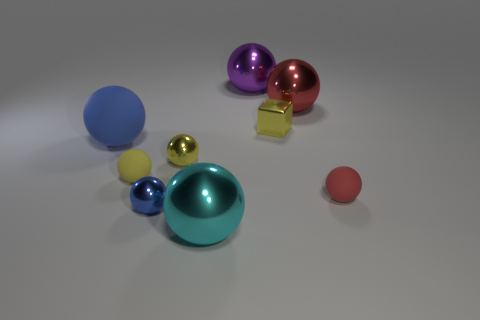Subtract all purple metal spheres. How many spheres are left? 7 Subtract all purple balls. How many balls are left? 7 Subtract all spheres. How many objects are left? 1 Subtract all small red metallic cylinders. Subtract all small yellow objects. How many objects are left? 6 Add 1 tiny red balls. How many tiny red balls are left? 2 Add 5 purple things. How many purple things exist? 6 Subtract 2 blue balls. How many objects are left? 7 Subtract 4 spheres. How many spheres are left? 4 Subtract all purple cubes. Subtract all yellow spheres. How many cubes are left? 1 Subtract all red blocks. How many brown spheres are left? 0 